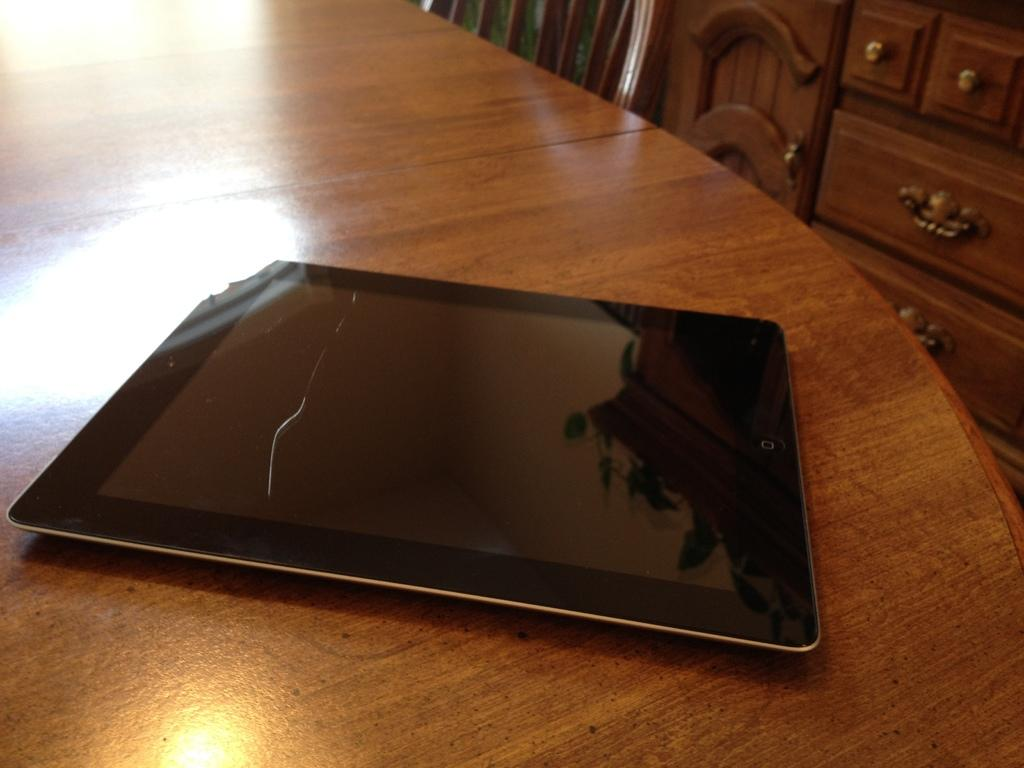What electronic device is on the wooden table in the image? There is an iPad on a wooden table in the image. What type of furniture is beside the wooden table? There is a chair beside the wooden table in the image. What other piece of furniture is present in the image? There is a cupboard with a desk in the image. What is reflected on the iPad's screen? The iPad reflects the cupboard in its screen. Where is the zoo located in the image? There is no zoo present in the image. What type of cellar is visible in the image? There is no cellar present in the image. 